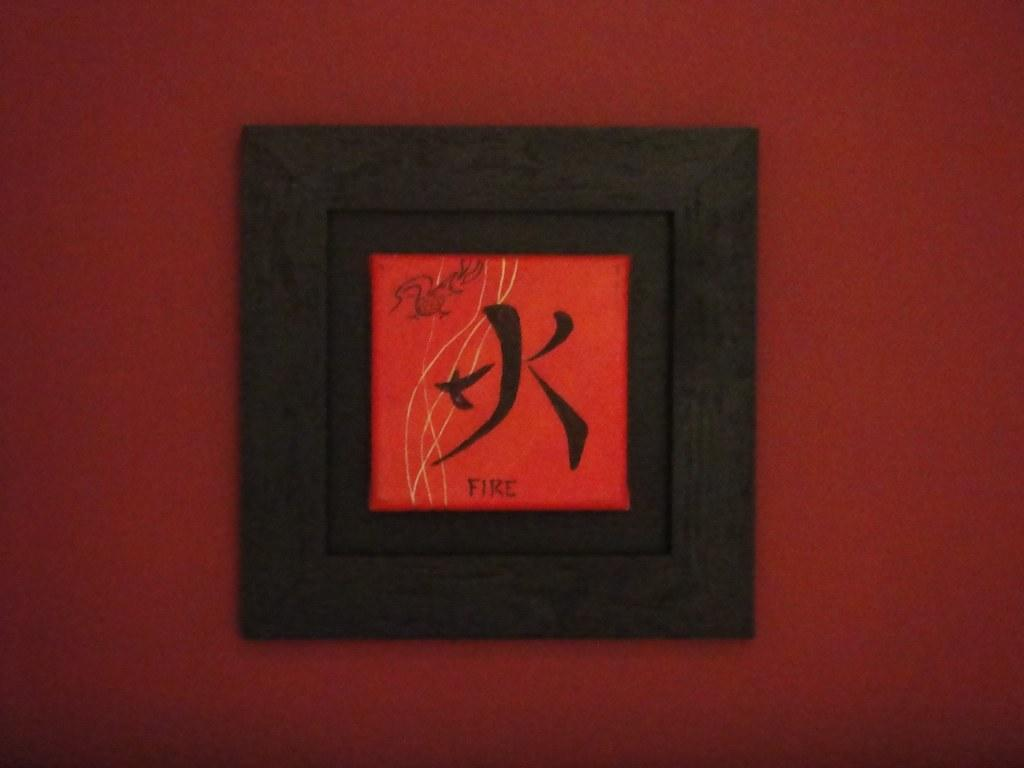What is present in the image that has a label? There is a label in the image. Can you see any ants crawling on the label in the image? There is no indication of ants present in the image. 